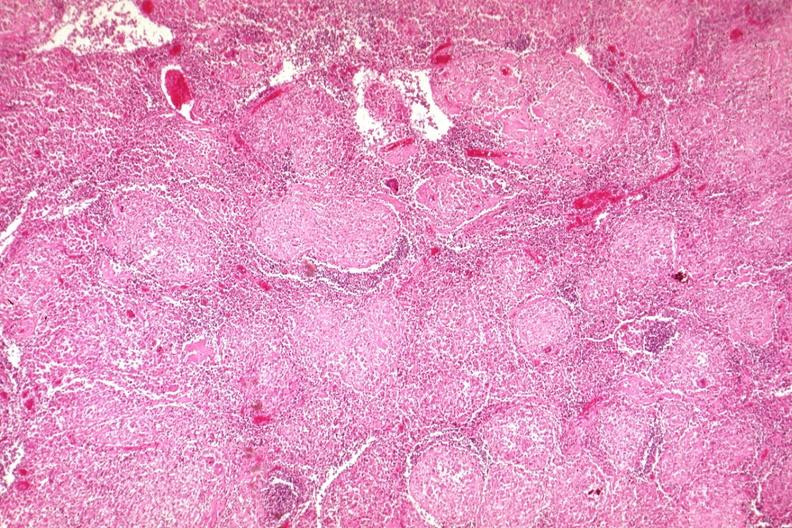s lymph node present?
Answer the question using a single word or phrase. Yes 